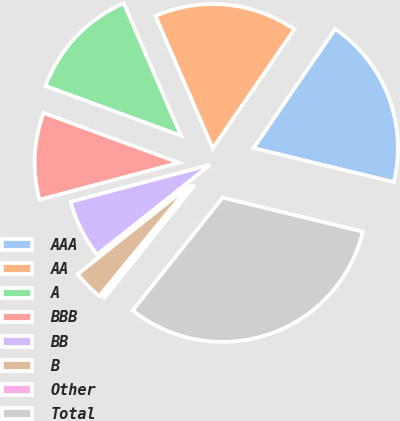Convert chart to OTSL. <chart><loc_0><loc_0><loc_500><loc_500><pie_chart><fcel>AAA<fcel>AA<fcel>A<fcel>BBB<fcel>BB<fcel>B<fcel>Other<fcel>Total<nl><fcel>19.23%<fcel>16.06%<fcel>12.9%<fcel>9.73%<fcel>6.56%<fcel>3.39%<fcel>0.22%<fcel>31.91%<nl></chart> 